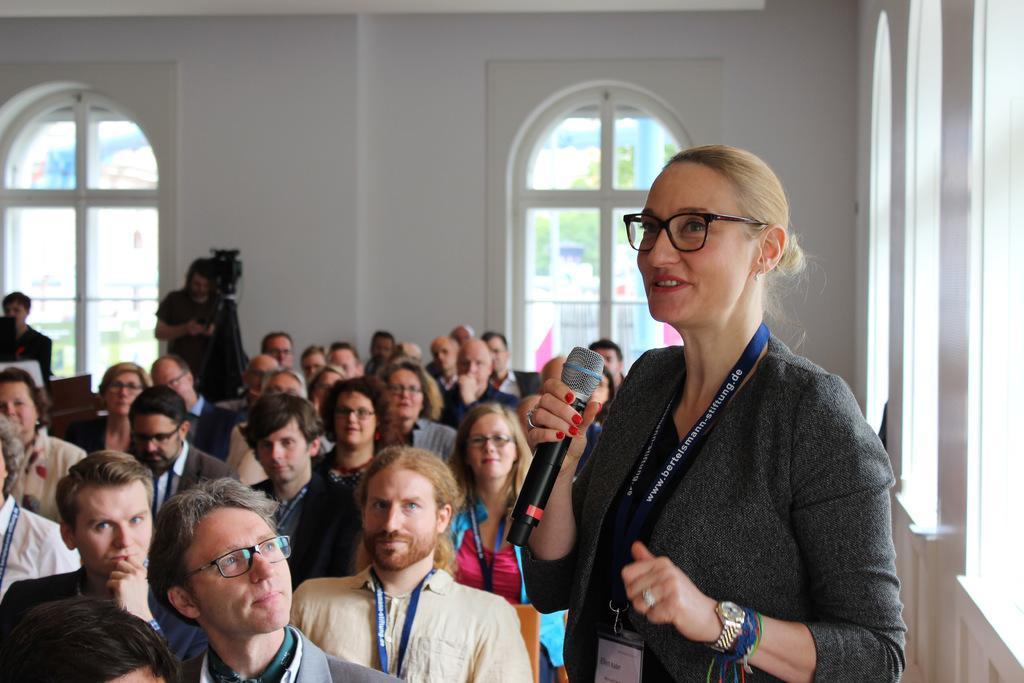How would you summarize this image in a sentence or two? In this image we can see a few people sitting, among them one person is standing and holding a mic, and the other person is holding an object, in front of him we can see a camera stand, there are some windows and the wall. 